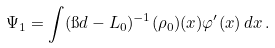<formula> <loc_0><loc_0><loc_500><loc_500>& \Psi _ { 1 } = \int ( \i d - \L L _ { 0 } ) ^ { - 1 } ( \rho _ { 0 } ) ( x ) \varphi ^ { \prime } ( x ) \, d x \, .</formula> 